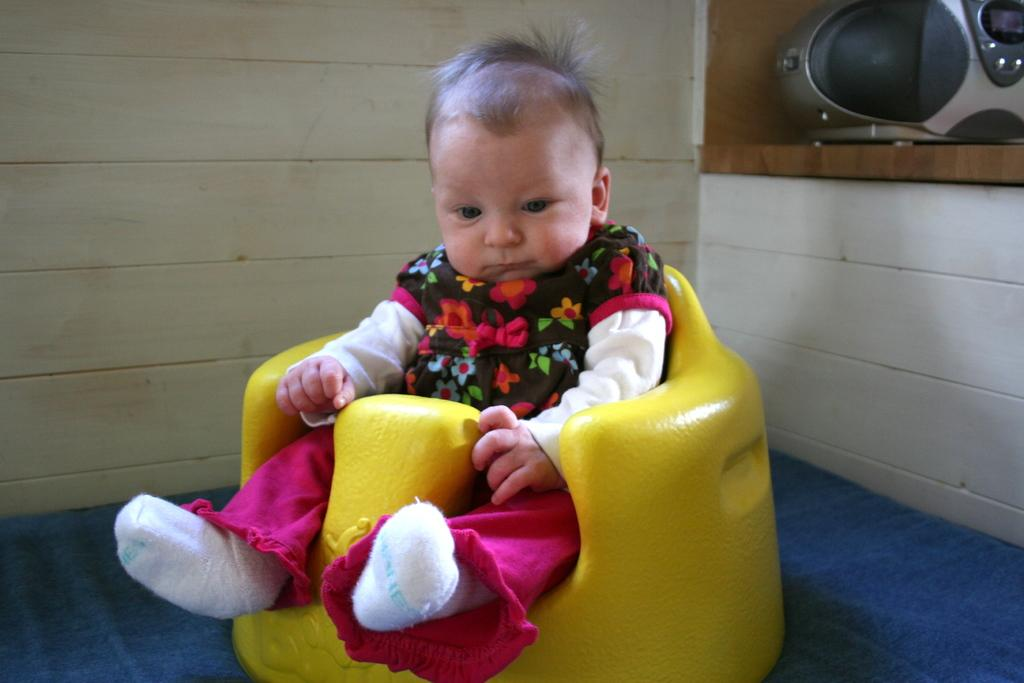What is the main subject of the image? There is a baby in the image. What is the baby doing in the image? The baby is seated on a chair. What can be seen in the background of the image? There is a wall in the background of the image. What type of flooring is present in the image? There is a carpet in the image. What type of wound can be seen on the baby's forehead in the image? There is no wound visible on the baby's forehead in the image. 